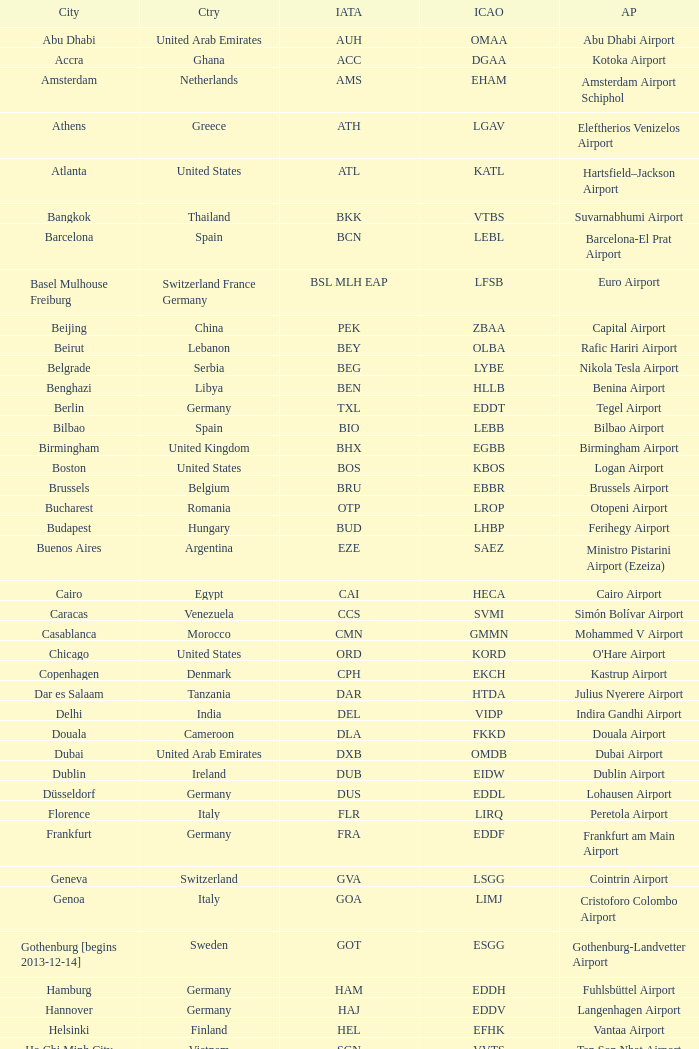What city is fuhlsbüttel airport in? Hamburg. Would you mind parsing the complete table? {'header': ['City', 'Ctry', 'IATA', 'ICAO', 'AP'], 'rows': [['Abu Dhabi', 'United Arab Emirates', 'AUH', 'OMAA', 'Abu Dhabi Airport'], ['Accra', 'Ghana', 'ACC', 'DGAA', 'Kotoka Airport'], ['Amsterdam', 'Netherlands', 'AMS', 'EHAM', 'Amsterdam Airport Schiphol'], ['Athens', 'Greece', 'ATH', 'LGAV', 'Eleftherios Venizelos Airport'], ['Atlanta', 'United States', 'ATL', 'KATL', 'Hartsfield–Jackson Airport'], ['Bangkok', 'Thailand', 'BKK', 'VTBS', 'Suvarnabhumi Airport'], ['Barcelona', 'Spain', 'BCN', 'LEBL', 'Barcelona-El Prat Airport'], ['Basel Mulhouse Freiburg', 'Switzerland France Germany', 'BSL MLH EAP', 'LFSB', 'Euro Airport'], ['Beijing', 'China', 'PEK', 'ZBAA', 'Capital Airport'], ['Beirut', 'Lebanon', 'BEY', 'OLBA', 'Rafic Hariri Airport'], ['Belgrade', 'Serbia', 'BEG', 'LYBE', 'Nikola Tesla Airport'], ['Benghazi', 'Libya', 'BEN', 'HLLB', 'Benina Airport'], ['Berlin', 'Germany', 'TXL', 'EDDT', 'Tegel Airport'], ['Bilbao', 'Spain', 'BIO', 'LEBB', 'Bilbao Airport'], ['Birmingham', 'United Kingdom', 'BHX', 'EGBB', 'Birmingham Airport'], ['Boston', 'United States', 'BOS', 'KBOS', 'Logan Airport'], ['Brussels', 'Belgium', 'BRU', 'EBBR', 'Brussels Airport'], ['Bucharest', 'Romania', 'OTP', 'LROP', 'Otopeni Airport'], ['Budapest', 'Hungary', 'BUD', 'LHBP', 'Ferihegy Airport'], ['Buenos Aires', 'Argentina', 'EZE', 'SAEZ', 'Ministro Pistarini Airport (Ezeiza)'], ['Cairo', 'Egypt', 'CAI', 'HECA', 'Cairo Airport'], ['Caracas', 'Venezuela', 'CCS', 'SVMI', 'Simón Bolívar Airport'], ['Casablanca', 'Morocco', 'CMN', 'GMMN', 'Mohammed V Airport'], ['Chicago', 'United States', 'ORD', 'KORD', "O'Hare Airport"], ['Copenhagen', 'Denmark', 'CPH', 'EKCH', 'Kastrup Airport'], ['Dar es Salaam', 'Tanzania', 'DAR', 'HTDA', 'Julius Nyerere Airport'], ['Delhi', 'India', 'DEL', 'VIDP', 'Indira Gandhi Airport'], ['Douala', 'Cameroon', 'DLA', 'FKKD', 'Douala Airport'], ['Dubai', 'United Arab Emirates', 'DXB', 'OMDB', 'Dubai Airport'], ['Dublin', 'Ireland', 'DUB', 'EIDW', 'Dublin Airport'], ['Düsseldorf', 'Germany', 'DUS', 'EDDL', 'Lohausen Airport'], ['Florence', 'Italy', 'FLR', 'LIRQ', 'Peretola Airport'], ['Frankfurt', 'Germany', 'FRA', 'EDDF', 'Frankfurt am Main Airport'], ['Geneva', 'Switzerland', 'GVA', 'LSGG', 'Cointrin Airport'], ['Genoa', 'Italy', 'GOA', 'LIMJ', 'Cristoforo Colombo Airport'], ['Gothenburg [begins 2013-12-14]', 'Sweden', 'GOT', 'ESGG', 'Gothenburg-Landvetter Airport'], ['Hamburg', 'Germany', 'HAM', 'EDDH', 'Fuhlsbüttel Airport'], ['Hannover', 'Germany', 'HAJ', 'EDDV', 'Langenhagen Airport'], ['Helsinki', 'Finland', 'HEL', 'EFHK', 'Vantaa Airport'], ['Ho Chi Minh City', 'Vietnam', 'SGN', 'VVTS', 'Tan Son Nhat Airport'], ['Hong Kong', 'Hong Kong', 'HKG', 'VHHH', 'Chek Lap Kok Airport'], ['Istanbul', 'Turkey', 'IST', 'LTBA', 'Atatürk Airport'], ['Jakarta', 'Indonesia', 'CGK', 'WIII', 'Soekarno–Hatta Airport'], ['Jeddah', 'Saudi Arabia', 'JED', 'OEJN', 'King Abdulaziz Airport'], ['Johannesburg', 'South Africa', 'JNB', 'FAJS', 'OR Tambo Airport'], ['Karachi', 'Pakistan', 'KHI', 'OPKC', 'Jinnah Airport'], ['Kiev', 'Ukraine', 'KBP', 'UKBB', 'Boryspil International Airport'], ['Lagos', 'Nigeria', 'LOS', 'DNMM', 'Murtala Muhammed Airport'], ['Libreville', 'Gabon', 'LBV', 'FOOL', "Leon M'ba Airport"], ['Lisbon', 'Portugal', 'LIS', 'LPPT', 'Portela Airport'], ['London', 'United Kingdom', 'LCY', 'EGLC', 'City Airport'], ['London [begins 2013-12-14]', 'United Kingdom', 'LGW', 'EGKK', 'Gatwick Airport'], ['London', 'United Kingdom', 'LHR', 'EGLL', 'Heathrow Airport'], ['Los Angeles', 'United States', 'LAX', 'KLAX', 'Los Angeles International Airport'], ['Lugano', 'Switzerland', 'LUG', 'LSZA', 'Agno Airport'], ['Luxembourg City', 'Luxembourg', 'LUX', 'ELLX', 'Findel Airport'], ['Lyon', 'France', 'LYS', 'LFLL', 'Saint-Exupéry Airport'], ['Madrid', 'Spain', 'MAD', 'LEMD', 'Madrid-Barajas Airport'], ['Malabo', 'Equatorial Guinea', 'SSG', 'FGSL', 'Saint Isabel Airport'], ['Malaga', 'Spain', 'AGP', 'LEMG', 'Málaga-Costa del Sol Airport'], ['Manchester', 'United Kingdom', 'MAN', 'EGCC', 'Ringway Airport'], ['Manila', 'Philippines', 'MNL', 'RPLL', 'Ninoy Aquino Airport'], ['Marrakech [begins 2013-11-01]', 'Morocco', 'RAK', 'GMMX', 'Menara Airport'], ['Miami', 'United States', 'MIA', 'KMIA', 'Miami Airport'], ['Milan', 'Italy', 'MXP', 'LIMC', 'Malpensa Airport'], ['Minneapolis', 'United States', 'MSP', 'KMSP', 'Minneapolis Airport'], ['Montreal', 'Canada', 'YUL', 'CYUL', 'Pierre Elliott Trudeau Airport'], ['Moscow', 'Russia', 'DME', 'UUDD', 'Domodedovo Airport'], ['Mumbai', 'India', 'BOM', 'VABB', 'Chhatrapati Shivaji Airport'], ['Munich', 'Germany', 'MUC', 'EDDM', 'Franz Josef Strauss Airport'], ['Muscat', 'Oman', 'MCT', 'OOMS', 'Seeb Airport'], ['Nairobi', 'Kenya', 'NBO', 'HKJK', 'Jomo Kenyatta Airport'], ['Newark', 'United States', 'EWR', 'KEWR', 'Liberty Airport'], ['New York City', 'United States', 'JFK', 'KJFK', 'John F Kennedy Airport'], ['Nice', 'France', 'NCE', 'LFMN', "Côte d'Azur Airport"], ['Nuremberg', 'Germany', 'NUE', 'EDDN', 'Nuremberg Airport'], ['Oslo', 'Norway', 'OSL', 'ENGM', 'Gardermoen Airport'], ['Palma de Mallorca', 'Spain', 'PMI', 'LFPA', 'Palma de Mallorca Airport'], ['Paris', 'France', 'CDG', 'LFPG', 'Charles de Gaulle Airport'], ['Porto', 'Portugal', 'OPO', 'LPPR', 'Francisco de Sa Carneiro Airport'], ['Prague', 'Czech Republic', 'PRG', 'LKPR', 'Ruzyně Airport'], ['Riga', 'Latvia', 'RIX', 'EVRA', 'Riga Airport'], ['Rio de Janeiro [resumes 2014-7-14]', 'Brazil', 'GIG', 'SBGL', 'Galeão Airport'], ['Riyadh', 'Saudi Arabia', 'RUH', 'OERK', 'King Khalid Airport'], ['Rome', 'Italy', 'FCO', 'LIRF', 'Leonardo da Vinci Airport'], ['Saint Petersburg', 'Russia', 'LED', 'ULLI', 'Pulkovo Airport'], ['San Francisco', 'United States', 'SFO', 'KSFO', 'San Francisco Airport'], ['Santiago', 'Chile', 'SCL', 'SCEL', 'Comodoro Arturo Benitez Airport'], ['São Paulo', 'Brazil', 'GRU', 'SBGR', 'Guarulhos Airport'], ['Sarajevo', 'Bosnia and Herzegovina', 'SJJ', 'LQSA', 'Butmir Airport'], ['Seattle', 'United States', 'SEA', 'KSEA', 'Sea-Tac Airport'], ['Shanghai', 'China', 'PVG', 'ZSPD', 'Pudong Airport'], ['Singapore', 'Singapore', 'SIN', 'WSSS', 'Changi Airport'], ['Skopje', 'Republic of Macedonia', 'SKP', 'LWSK', 'Alexander the Great Airport'], ['Sofia', 'Bulgaria', 'SOF', 'LBSF', 'Vrazhdebna Airport'], ['Stockholm', 'Sweden', 'ARN', 'ESSA', 'Arlanda Airport'], ['Stuttgart', 'Germany', 'STR', 'EDDS', 'Echterdingen Airport'], ['Taipei', 'Taiwan', 'TPE', 'RCTP', 'Taoyuan Airport'], ['Tehran', 'Iran', 'IKA', 'OIIE', 'Imam Khomeini Airport'], ['Tel Aviv', 'Israel', 'TLV', 'LLBG', 'Ben Gurion Airport'], ['Thessaloniki', 'Greece', 'SKG', 'LGTS', 'Macedonia Airport'], ['Tirana', 'Albania', 'TIA', 'LATI', 'Nënë Tereza Airport'], ['Tokyo', 'Japan', 'NRT', 'RJAA', 'Narita Airport'], ['Toronto', 'Canada', 'YYZ', 'CYYZ', 'Pearson Airport'], ['Tripoli', 'Libya', 'TIP', 'HLLT', 'Tripoli Airport'], ['Tunis', 'Tunisia', 'TUN', 'DTTA', 'Carthage Airport'], ['Turin', 'Italy', 'TRN', 'LIMF', 'Sandro Pertini Airport'], ['Valencia', 'Spain', 'VLC', 'LEVC', 'Valencia Airport'], ['Venice', 'Italy', 'VCE', 'LIPZ', 'Marco Polo Airport'], ['Vienna', 'Austria', 'VIE', 'LOWW', 'Schwechat Airport'], ['Warsaw', 'Poland', 'WAW', 'EPWA', 'Frederic Chopin Airport'], ['Washington DC', 'United States', 'IAD', 'KIAD', 'Dulles Airport'], ['Yaounde', 'Cameroon', 'NSI', 'FKYS', 'Yaounde Nsimalen Airport'], ['Yerevan', 'Armenia', 'EVN', 'UDYZ', 'Zvartnots Airport'], ['Zurich', 'Switzerland', 'ZRH', 'LSZH', 'Zurich Airport']]} 